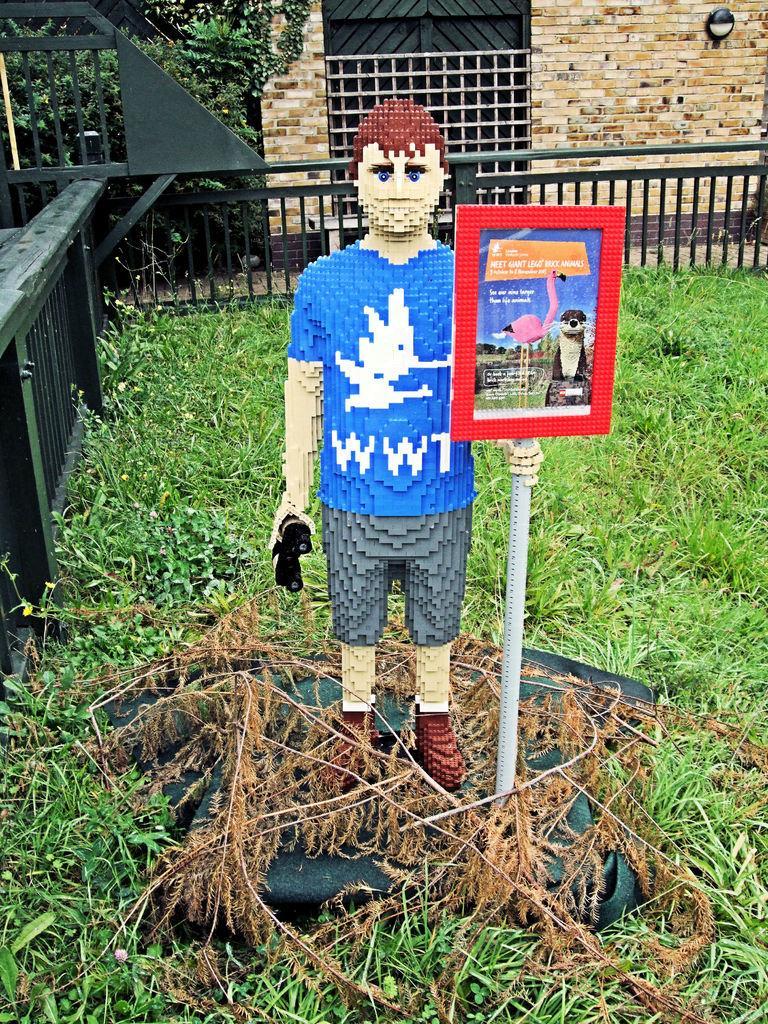Can you describe this image briefly? In the center of the image we can see a statue. At the bottom there is grass. In the background there is a fence, a wall and a gate. 